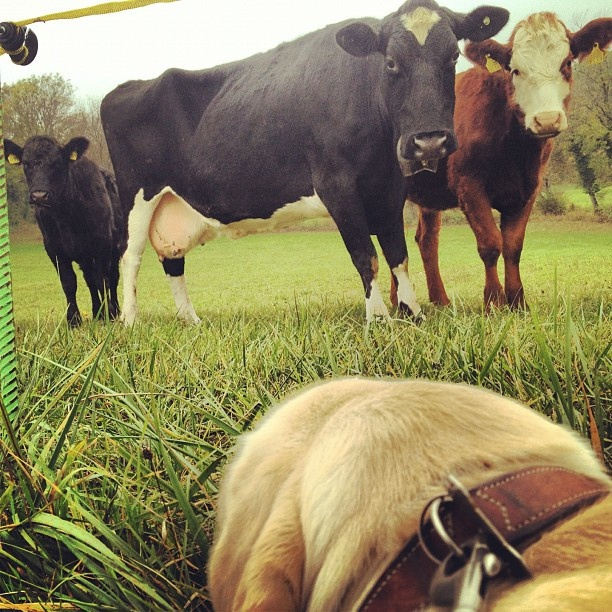Describe the objects in this image and their specific colors. I can see dog in white, khaki, tan, and brown tones, cow in white, gray, black, and darkgray tones, cow in white, black, maroon, tan, and khaki tones, and cow in white, black, and gray tones in this image. 